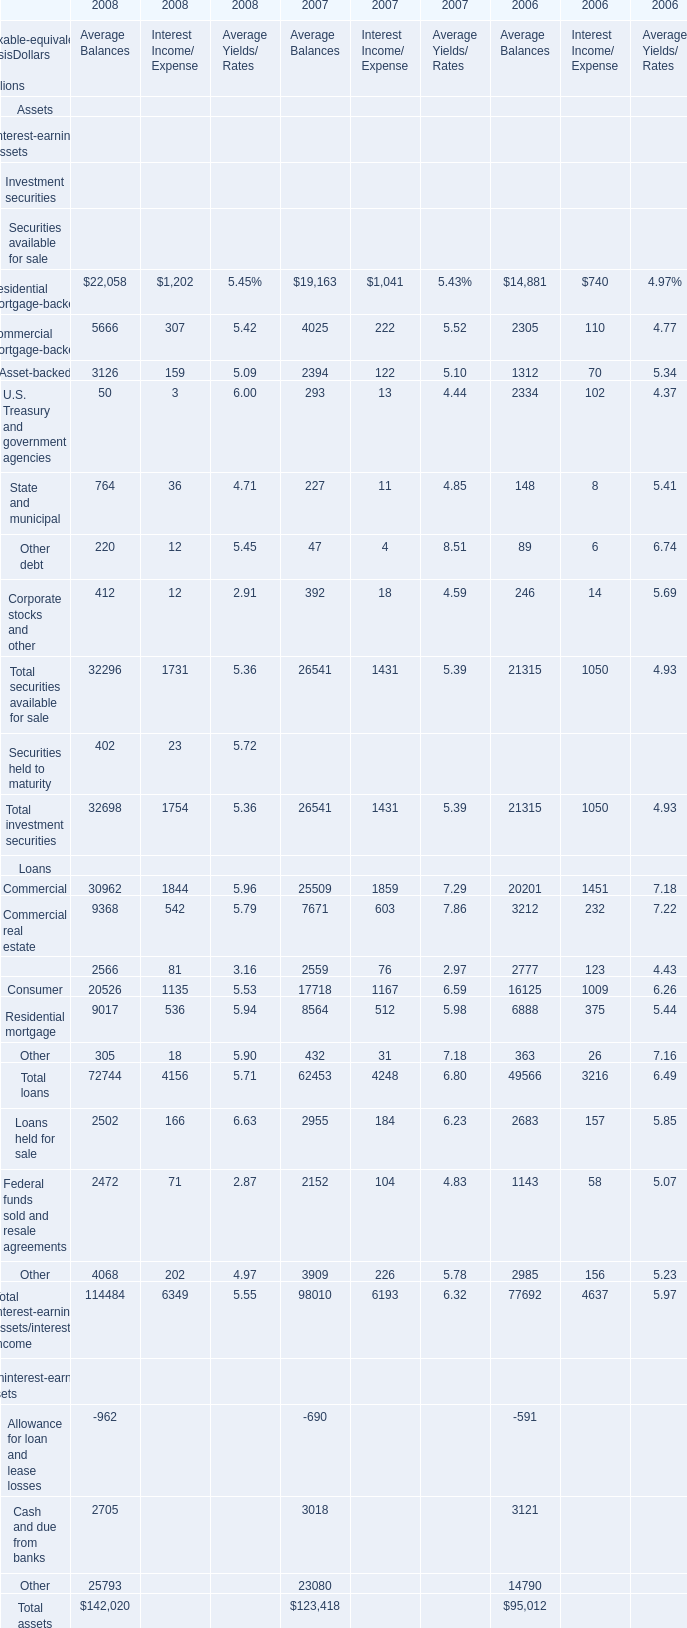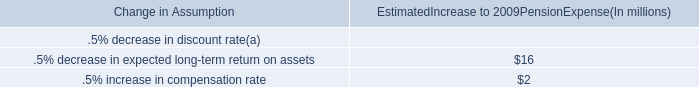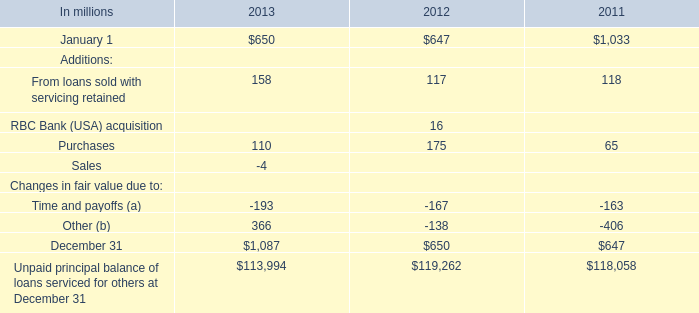What is the average value of Cash and due from banks of Noninterest-earning assets in 2008, 2007, and 2006 for Average Balances? (in million) 
Computations: (((2705 + 3018) + 3121) / 3)
Answer: 2948.0. 